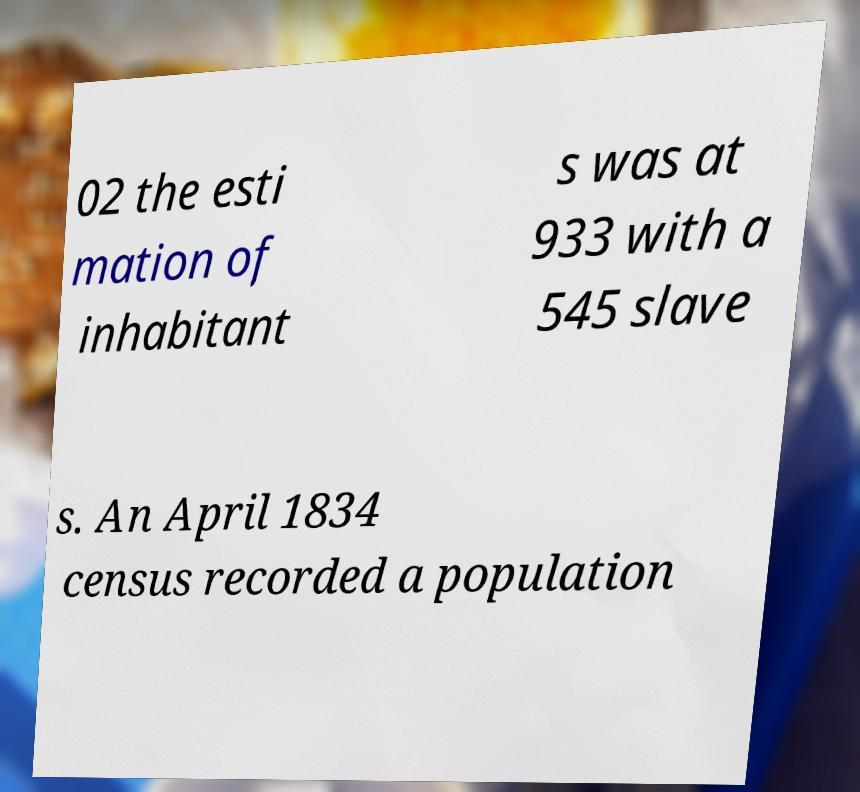Please identify and transcribe the text found in this image. 02 the esti mation of inhabitant s was at 933 with a 545 slave s. An April 1834 census recorded a population 